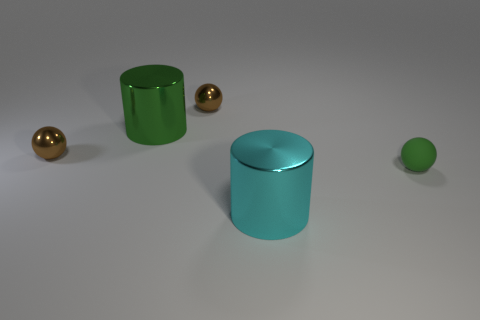Are the cyan object and the small green thing made of the same material?
Offer a terse response. No. How many large gray metal cylinders are there?
Make the answer very short. 0. The tiny shiny ball that is to the left of the brown shiny sphere that is right of the big metal thing that is behind the cyan thing is what color?
Give a very brief answer. Brown. What number of things are both in front of the tiny rubber thing and behind the large green object?
Make the answer very short. 0. How many metal objects are either big objects or green cylinders?
Give a very brief answer. 2. There is a big thing that is in front of the large object that is to the left of the big cyan thing; what is its material?
Your answer should be compact. Metal. There is a big thing that is the same color as the tiny matte object; what is its shape?
Ensure brevity in your answer.  Cylinder. Is the number of small shiny spheres less than the number of cyan metal things?
Give a very brief answer. No. There is a big cylinder right of the green metallic object; is there a brown ball that is in front of it?
Your answer should be very brief. No. What is the shape of the large cyan thing that is made of the same material as the big green thing?
Provide a short and direct response. Cylinder. 